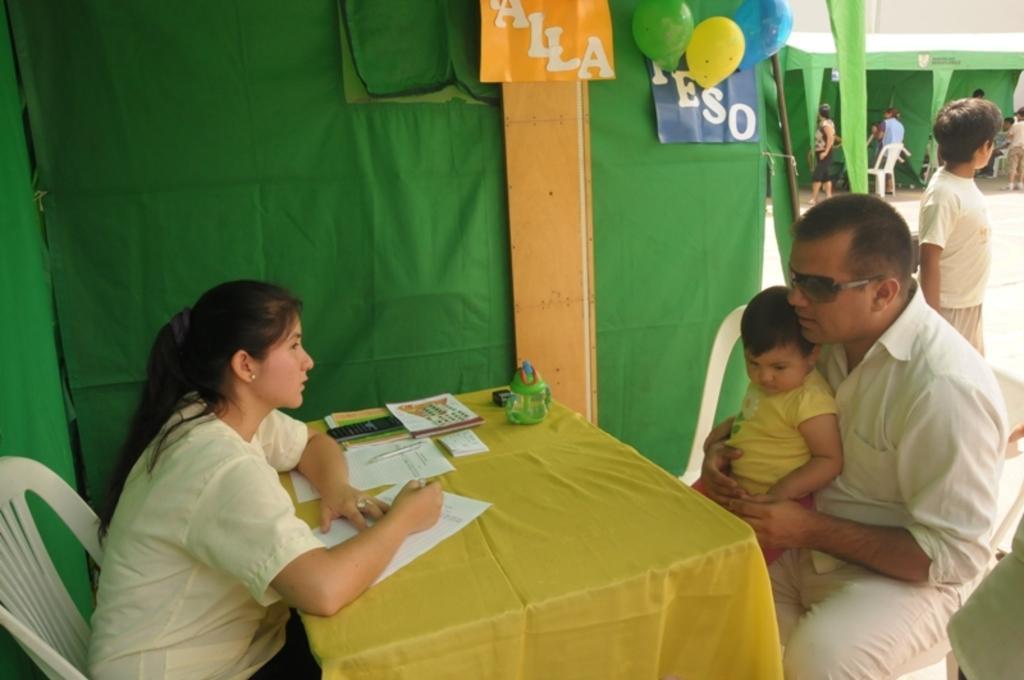Could you give a brief overview of what you see in this image? In this picture we can see two persons sitting on the chairs. He has goggles and he is holding a baby with his hands. This is table. On the table there is a cloth, diapers, and a pen. On the background there is a cloth and these are the posters. Here we can see some persons standing on the road. And these are the balloons. 